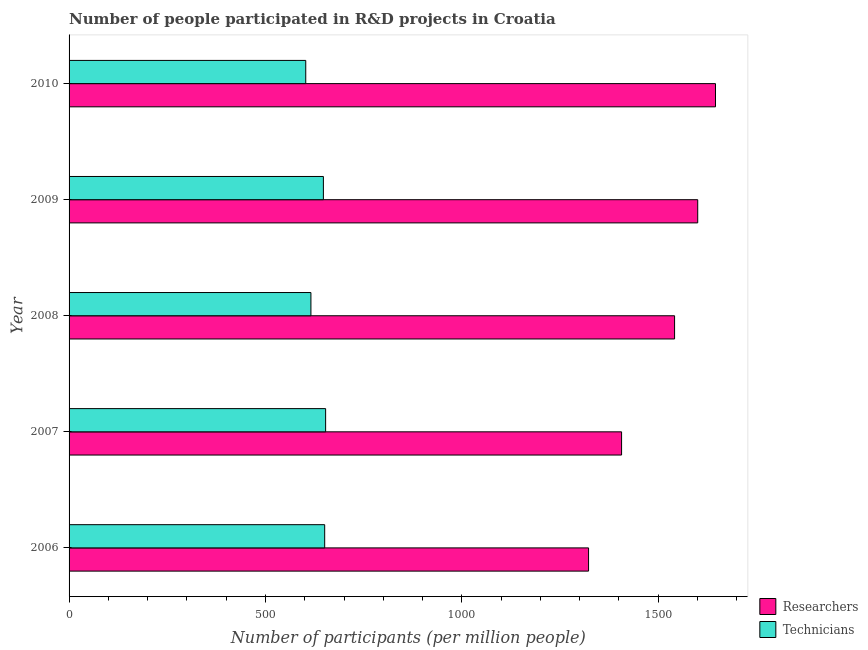Are the number of bars on each tick of the Y-axis equal?
Provide a succinct answer. Yes. What is the number of technicians in 2007?
Provide a short and direct response. 653.18. Across all years, what is the maximum number of technicians?
Your response must be concise. 653.18. Across all years, what is the minimum number of technicians?
Keep it short and to the point. 602.58. In which year was the number of technicians minimum?
Ensure brevity in your answer.  2010. What is the total number of researchers in the graph?
Give a very brief answer. 7517.28. What is the difference between the number of researchers in 2007 and that in 2010?
Ensure brevity in your answer.  -239.14. What is the difference between the number of technicians in 2006 and the number of researchers in 2010?
Offer a very short reply. -995.01. What is the average number of researchers per year?
Provide a short and direct response. 1503.45. In the year 2007, what is the difference between the number of technicians and number of researchers?
Offer a terse response. -753.48. In how many years, is the number of technicians greater than 800 ?
Offer a very short reply. 0. What is the ratio of the number of technicians in 2009 to that in 2010?
Offer a very short reply. 1.07. Is the difference between the number of researchers in 2006 and 2010 greater than the difference between the number of technicians in 2006 and 2010?
Offer a terse response. No. What is the difference between the highest and the second highest number of technicians?
Provide a succinct answer. 2.39. What is the difference between the highest and the lowest number of technicians?
Offer a very short reply. 50.6. In how many years, is the number of researchers greater than the average number of researchers taken over all years?
Your answer should be compact. 3. Is the sum of the number of researchers in 2008 and 2009 greater than the maximum number of technicians across all years?
Make the answer very short. Yes. What does the 1st bar from the top in 2009 represents?
Offer a terse response. Technicians. What does the 2nd bar from the bottom in 2006 represents?
Offer a terse response. Technicians. Are all the bars in the graph horizontal?
Ensure brevity in your answer.  Yes. Does the graph contain grids?
Make the answer very short. No. How many legend labels are there?
Offer a terse response. 2. What is the title of the graph?
Provide a short and direct response. Number of people participated in R&D projects in Croatia. Does "Attending school" appear as one of the legend labels in the graph?
Provide a succinct answer. No. What is the label or title of the X-axis?
Make the answer very short. Number of participants (per million people). What is the label or title of the Y-axis?
Your answer should be compact. Year. What is the Number of participants (per million people) of Researchers in 2006?
Make the answer very short. 1322.65. What is the Number of participants (per million people) of Technicians in 2006?
Provide a succinct answer. 650.79. What is the Number of participants (per million people) of Researchers in 2007?
Keep it short and to the point. 1406.67. What is the Number of participants (per million people) in Technicians in 2007?
Your answer should be compact. 653.18. What is the Number of participants (per million people) in Researchers in 2008?
Make the answer very short. 1541.61. What is the Number of participants (per million people) of Technicians in 2008?
Your answer should be compact. 615.77. What is the Number of participants (per million people) of Researchers in 2009?
Offer a terse response. 1600.55. What is the Number of participants (per million people) in Technicians in 2009?
Ensure brevity in your answer.  647.52. What is the Number of participants (per million people) of Researchers in 2010?
Keep it short and to the point. 1645.81. What is the Number of participants (per million people) in Technicians in 2010?
Offer a terse response. 602.58. Across all years, what is the maximum Number of participants (per million people) in Researchers?
Offer a very short reply. 1645.81. Across all years, what is the maximum Number of participants (per million people) in Technicians?
Offer a terse response. 653.18. Across all years, what is the minimum Number of participants (per million people) in Researchers?
Give a very brief answer. 1322.65. Across all years, what is the minimum Number of participants (per million people) of Technicians?
Offer a terse response. 602.58. What is the total Number of participants (per million people) in Researchers in the graph?
Your answer should be compact. 7517.28. What is the total Number of participants (per million people) of Technicians in the graph?
Your response must be concise. 3169.85. What is the difference between the Number of participants (per million people) in Researchers in 2006 and that in 2007?
Keep it short and to the point. -84.02. What is the difference between the Number of participants (per million people) in Technicians in 2006 and that in 2007?
Provide a succinct answer. -2.39. What is the difference between the Number of participants (per million people) in Researchers in 2006 and that in 2008?
Provide a succinct answer. -218.97. What is the difference between the Number of participants (per million people) in Technicians in 2006 and that in 2008?
Give a very brief answer. 35.02. What is the difference between the Number of participants (per million people) of Researchers in 2006 and that in 2009?
Ensure brevity in your answer.  -277.9. What is the difference between the Number of participants (per million people) in Technicians in 2006 and that in 2009?
Your answer should be very brief. 3.28. What is the difference between the Number of participants (per million people) in Researchers in 2006 and that in 2010?
Make the answer very short. -323.16. What is the difference between the Number of participants (per million people) of Technicians in 2006 and that in 2010?
Keep it short and to the point. 48.21. What is the difference between the Number of participants (per million people) of Researchers in 2007 and that in 2008?
Your response must be concise. -134.95. What is the difference between the Number of participants (per million people) of Technicians in 2007 and that in 2008?
Provide a short and direct response. 37.41. What is the difference between the Number of participants (per million people) of Researchers in 2007 and that in 2009?
Make the answer very short. -193.88. What is the difference between the Number of participants (per million people) in Technicians in 2007 and that in 2009?
Your response must be concise. 5.67. What is the difference between the Number of participants (per million people) in Researchers in 2007 and that in 2010?
Ensure brevity in your answer.  -239.14. What is the difference between the Number of participants (per million people) of Technicians in 2007 and that in 2010?
Ensure brevity in your answer.  50.6. What is the difference between the Number of participants (per million people) in Researchers in 2008 and that in 2009?
Provide a short and direct response. -58.93. What is the difference between the Number of participants (per million people) in Technicians in 2008 and that in 2009?
Your answer should be compact. -31.74. What is the difference between the Number of participants (per million people) in Researchers in 2008 and that in 2010?
Offer a terse response. -104.19. What is the difference between the Number of participants (per million people) in Technicians in 2008 and that in 2010?
Ensure brevity in your answer.  13.19. What is the difference between the Number of participants (per million people) of Researchers in 2009 and that in 2010?
Ensure brevity in your answer.  -45.26. What is the difference between the Number of participants (per million people) in Technicians in 2009 and that in 2010?
Offer a terse response. 44.93. What is the difference between the Number of participants (per million people) in Researchers in 2006 and the Number of participants (per million people) in Technicians in 2007?
Make the answer very short. 669.46. What is the difference between the Number of participants (per million people) of Researchers in 2006 and the Number of participants (per million people) of Technicians in 2008?
Make the answer very short. 706.87. What is the difference between the Number of participants (per million people) in Researchers in 2006 and the Number of participants (per million people) in Technicians in 2009?
Keep it short and to the point. 675.13. What is the difference between the Number of participants (per million people) of Researchers in 2006 and the Number of participants (per million people) of Technicians in 2010?
Provide a short and direct response. 720.06. What is the difference between the Number of participants (per million people) of Researchers in 2007 and the Number of participants (per million people) of Technicians in 2008?
Ensure brevity in your answer.  790.89. What is the difference between the Number of participants (per million people) of Researchers in 2007 and the Number of participants (per million people) of Technicians in 2009?
Offer a very short reply. 759.15. What is the difference between the Number of participants (per million people) of Researchers in 2007 and the Number of participants (per million people) of Technicians in 2010?
Offer a very short reply. 804.08. What is the difference between the Number of participants (per million people) of Researchers in 2008 and the Number of participants (per million people) of Technicians in 2009?
Your response must be concise. 894.1. What is the difference between the Number of participants (per million people) of Researchers in 2008 and the Number of participants (per million people) of Technicians in 2010?
Your answer should be compact. 939.03. What is the difference between the Number of participants (per million people) in Researchers in 2009 and the Number of participants (per million people) in Technicians in 2010?
Provide a short and direct response. 997.96. What is the average Number of participants (per million people) in Researchers per year?
Your answer should be compact. 1503.46. What is the average Number of participants (per million people) in Technicians per year?
Keep it short and to the point. 633.97. In the year 2006, what is the difference between the Number of participants (per million people) of Researchers and Number of participants (per million people) of Technicians?
Give a very brief answer. 671.85. In the year 2007, what is the difference between the Number of participants (per million people) of Researchers and Number of participants (per million people) of Technicians?
Offer a terse response. 753.48. In the year 2008, what is the difference between the Number of participants (per million people) in Researchers and Number of participants (per million people) in Technicians?
Ensure brevity in your answer.  925.84. In the year 2009, what is the difference between the Number of participants (per million people) of Researchers and Number of participants (per million people) of Technicians?
Give a very brief answer. 953.03. In the year 2010, what is the difference between the Number of participants (per million people) of Researchers and Number of participants (per million people) of Technicians?
Ensure brevity in your answer.  1043.22. What is the ratio of the Number of participants (per million people) of Researchers in 2006 to that in 2007?
Give a very brief answer. 0.94. What is the ratio of the Number of participants (per million people) in Technicians in 2006 to that in 2007?
Make the answer very short. 1. What is the ratio of the Number of participants (per million people) in Researchers in 2006 to that in 2008?
Provide a short and direct response. 0.86. What is the ratio of the Number of participants (per million people) of Technicians in 2006 to that in 2008?
Your response must be concise. 1.06. What is the ratio of the Number of participants (per million people) in Researchers in 2006 to that in 2009?
Offer a terse response. 0.83. What is the ratio of the Number of participants (per million people) of Researchers in 2006 to that in 2010?
Make the answer very short. 0.8. What is the ratio of the Number of participants (per million people) in Technicians in 2006 to that in 2010?
Your answer should be compact. 1.08. What is the ratio of the Number of participants (per million people) in Researchers in 2007 to that in 2008?
Your answer should be compact. 0.91. What is the ratio of the Number of participants (per million people) of Technicians in 2007 to that in 2008?
Your response must be concise. 1.06. What is the ratio of the Number of participants (per million people) in Researchers in 2007 to that in 2009?
Your answer should be very brief. 0.88. What is the ratio of the Number of participants (per million people) in Technicians in 2007 to that in 2009?
Give a very brief answer. 1.01. What is the ratio of the Number of participants (per million people) of Researchers in 2007 to that in 2010?
Offer a terse response. 0.85. What is the ratio of the Number of participants (per million people) in Technicians in 2007 to that in 2010?
Keep it short and to the point. 1.08. What is the ratio of the Number of participants (per million people) in Researchers in 2008 to that in 2009?
Ensure brevity in your answer.  0.96. What is the ratio of the Number of participants (per million people) in Technicians in 2008 to that in 2009?
Your answer should be compact. 0.95. What is the ratio of the Number of participants (per million people) in Researchers in 2008 to that in 2010?
Your response must be concise. 0.94. What is the ratio of the Number of participants (per million people) of Technicians in 2008 to that in 2010?
Your answer should be compact. 1.02. What is the ratio of the Number of participants (per million people) of Researchers in 2009 to that in 2010?
Provide a short and direct response. 0.97. What is the ratio of the Number of participants (per million people) in Technicians in 2009 to that in 2010?
Provide a succinct answer. 1.07. What is the difference between the highest and the second highest Number of participants (per million people) of Researchers?
Ensure brevity in your answer.  45.26. What is the difference between the highest and the second highest Number of participants (per million people) of Technicians?
Your answer should be very brief. 2.39. What is the difference between the highest and the lowest Number of participants (per million people) of Researchers?
Your response must be concise. 323.16. What is the difference between the highest and the lowest Number of participants (per million people) in Technicians?
Give a very brief answer. 50.6. 